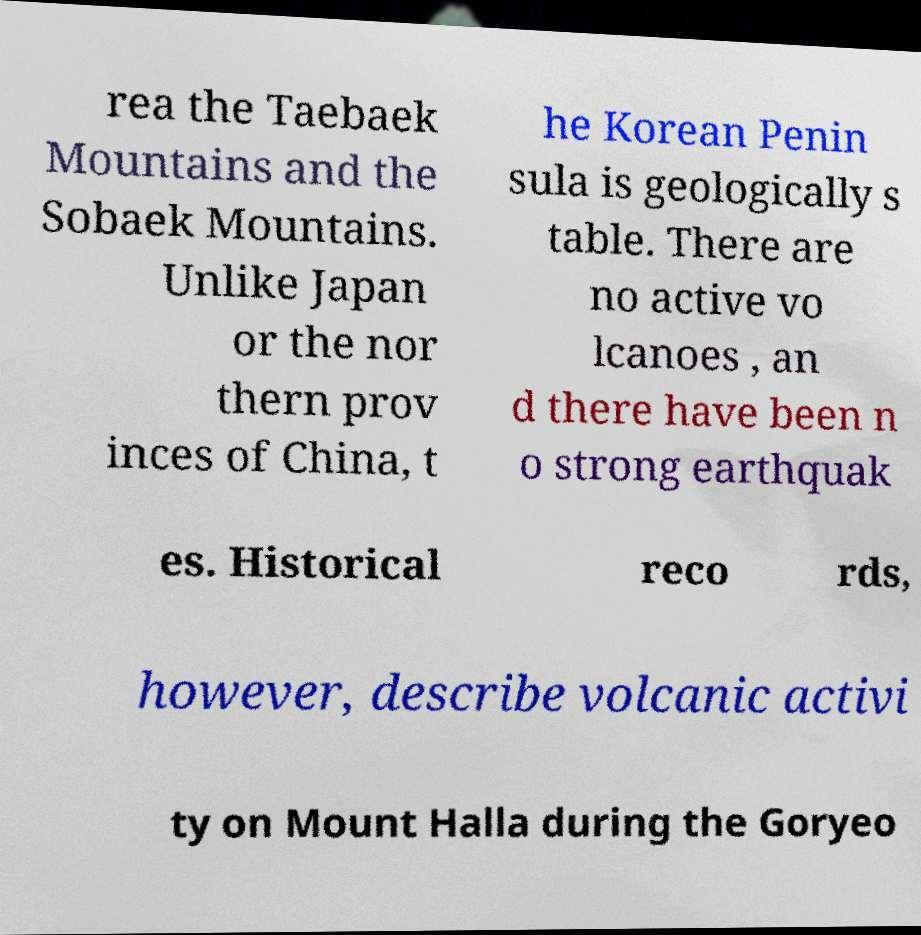Please read and relay the text visible in this image. What does it say? rea the Taebaek Mountains and the Sobaek Mountains. Unlike Japan or the nor thern prov inces of China, t he Korean Penin sula is geologically s table. There are no active vo lcanoes , an d there have been n o strong earthquak es. Historical reco rds, however, describe volcanic activi ty on Mount Halla during the Goryeo 